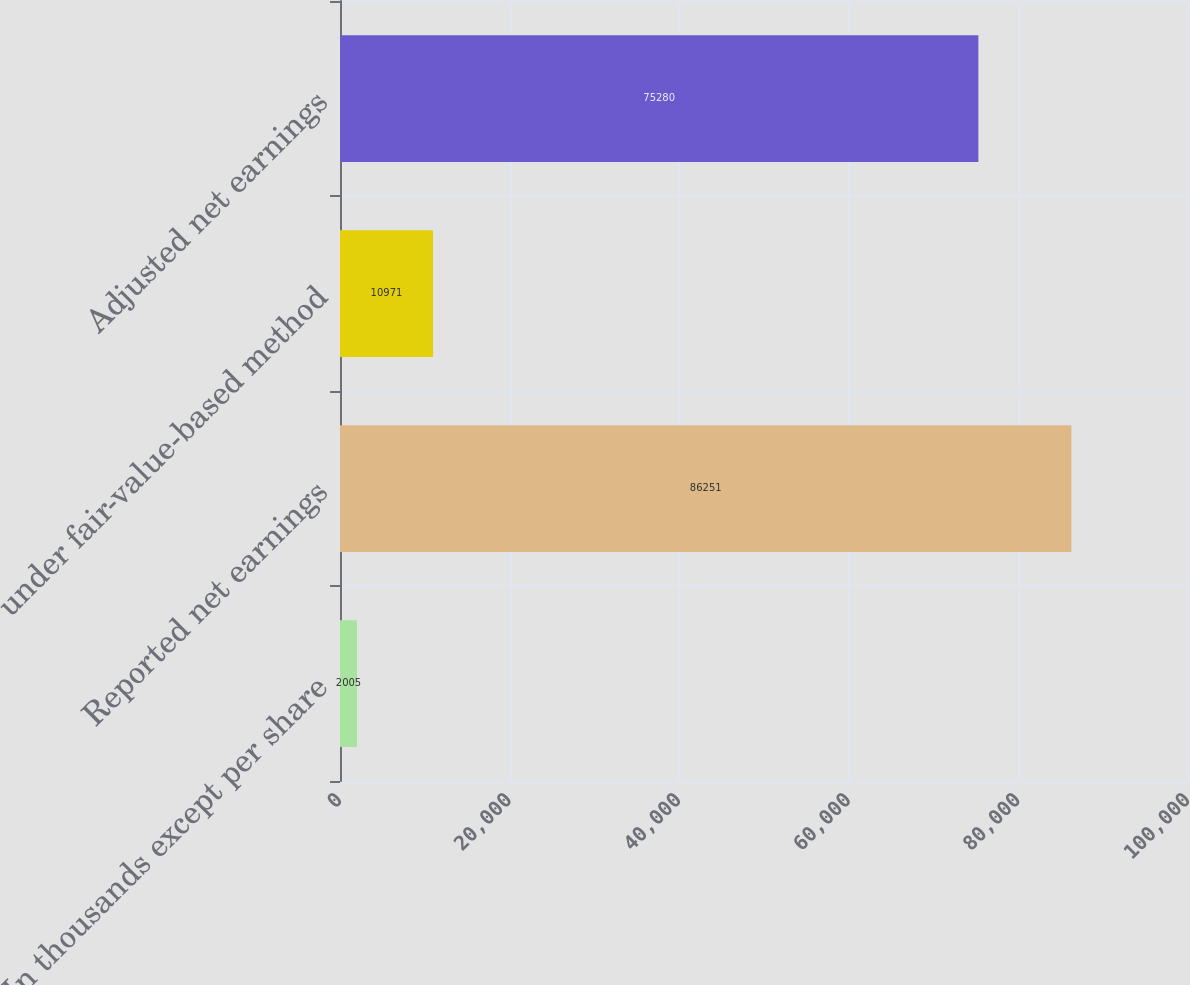<chart> <loc_0><loc_0><loc_500><loc_500><bar_chart><fcel>(In thousands except per share<fcel>Reported net earnings<fcel>under fair-value-based method<fcel>Adjusted net earnings<nl><fcel>2005<fcel>86251<fcel>10971<fcel>75280<nl></chart> 